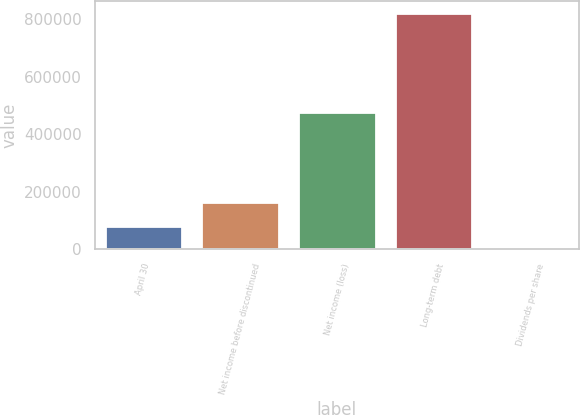<chart> <loc_0><loc_0><loc_500><loc_500><bar_chart><fcel>April 30<fcel>Net income before discontinued<fcel>Net income (loss)<fcel>Long-term debt<fcel>Dividends per share<nl><fcel>82229<fcel>164458<fcel>477615<fcel>822287<fcel>0.35<nl></chart> 